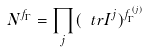<formula> <loc_0><loc_0><loc_500><loc_500>N ^ { f _ { \Gamma } } = \prod _ { j } ( \ t r I ^ { j } ) ^ { f _ { \Gamma } ^ { ( j ) } }</formula> 